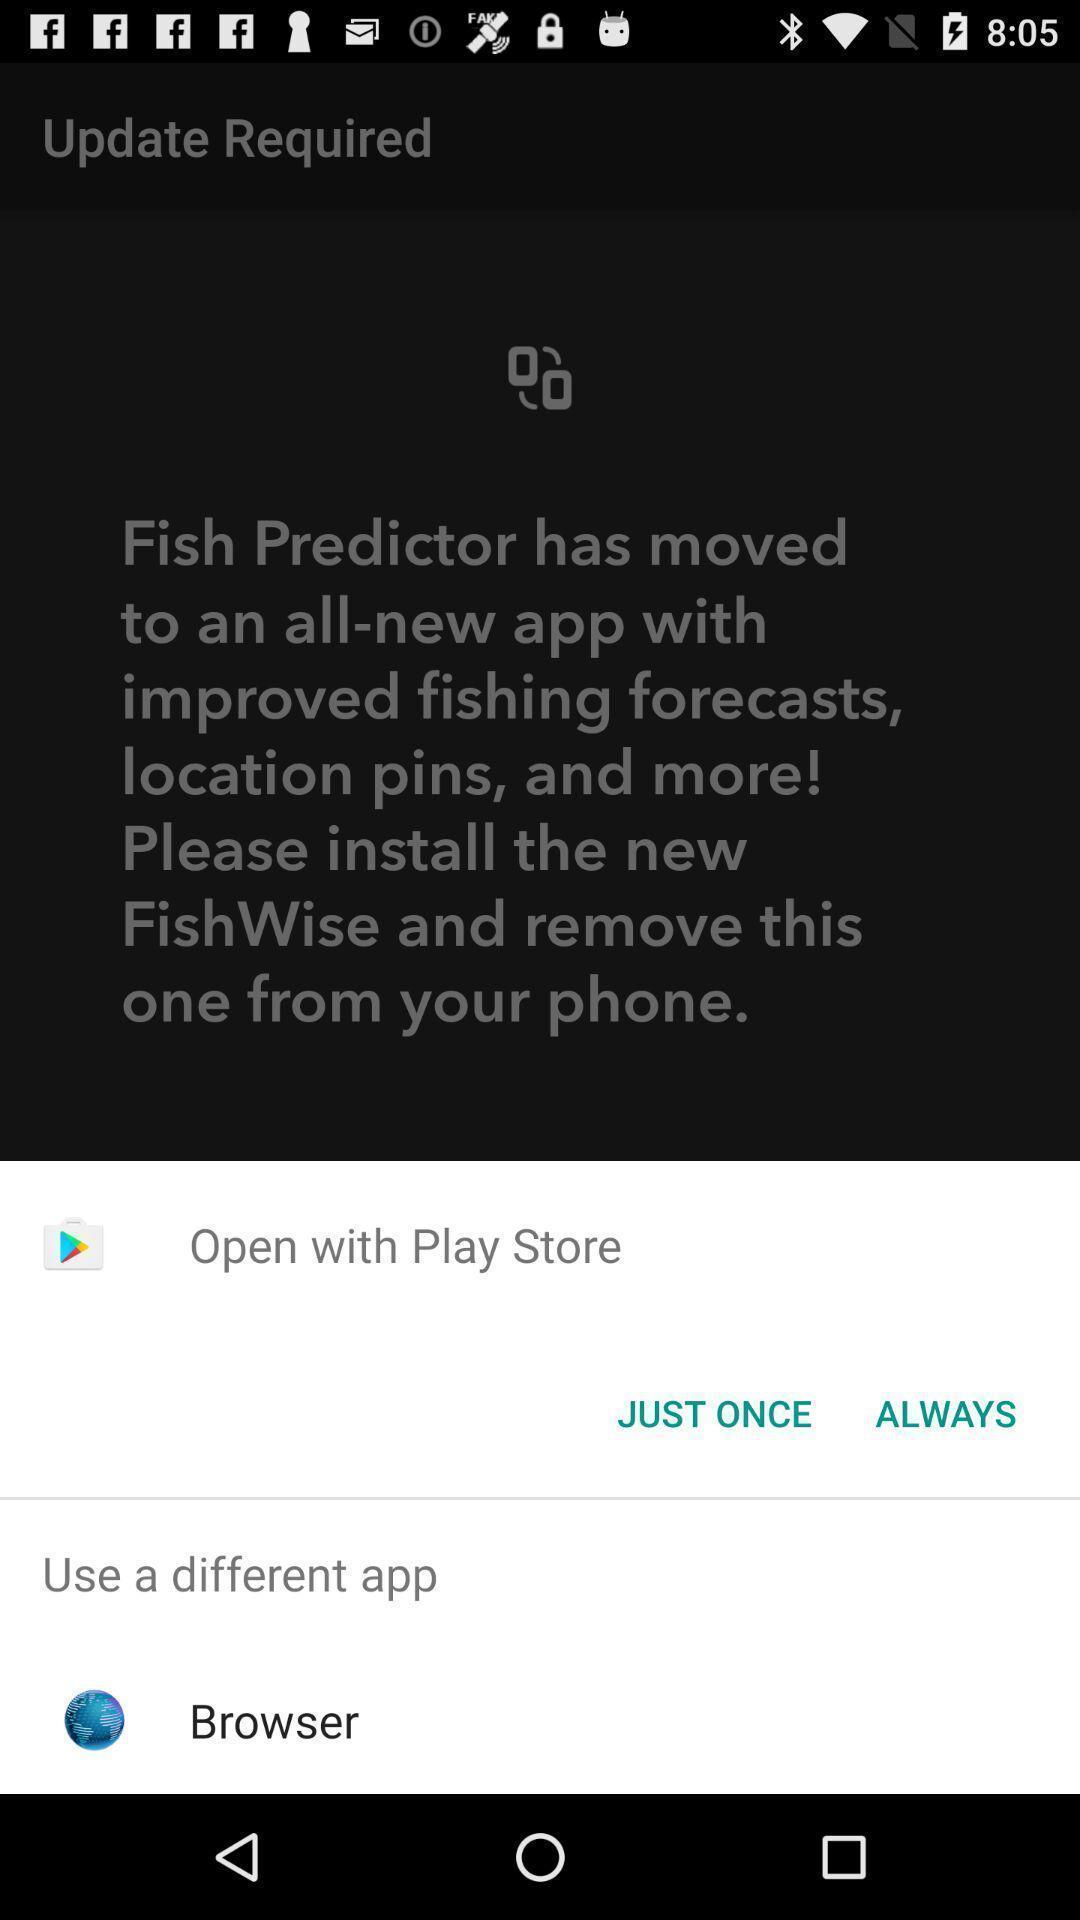Explain the elements present in this screenshot. Push up page showing app preference to open. 